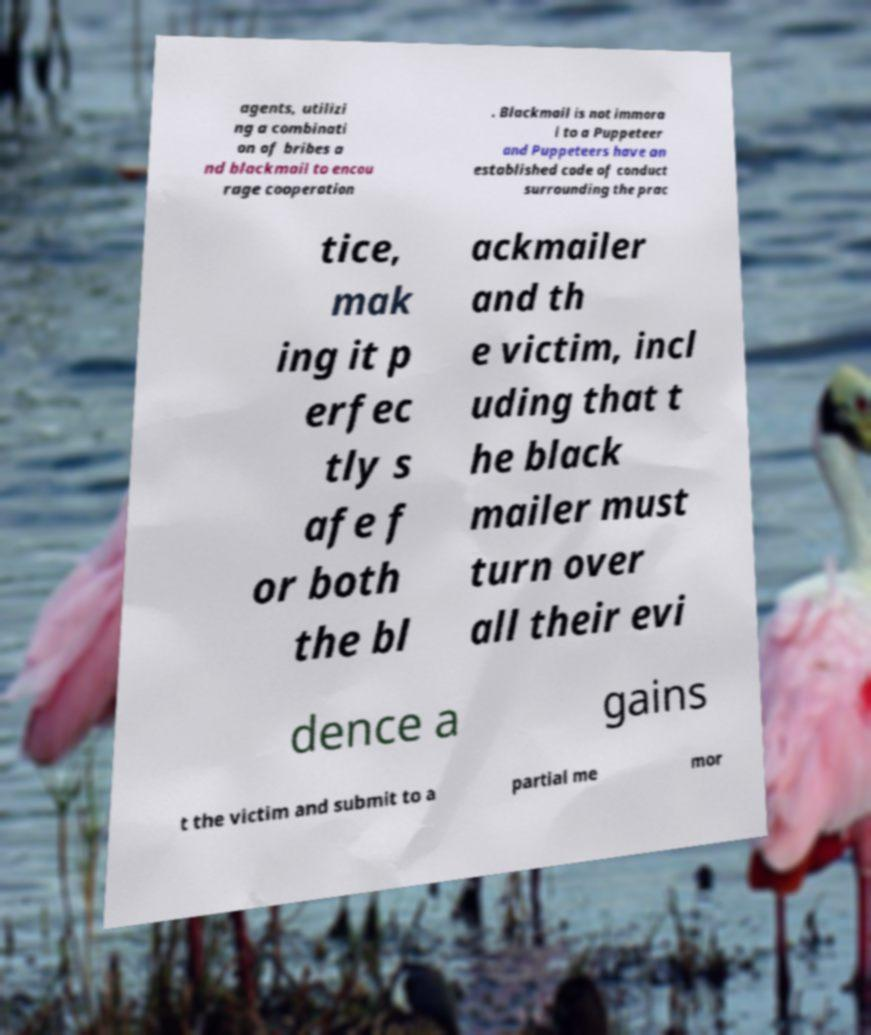For documentation purposes, I need the text within this image transcribed. Could you provide that? agents, utilizi ng a combinati on of bribes a nd blackmail to encou rage cooperation . Blackmail is not immora l to a Puppeteer and Puppeteers have an established code of conduct surrounding the prac tice, mak ing it p erfec tly s afe f or both the bl ackmailer and th e victim, incl uding that t he black mailer must turn over all their evi dence a gains t the victim and submit to a partial me mor 